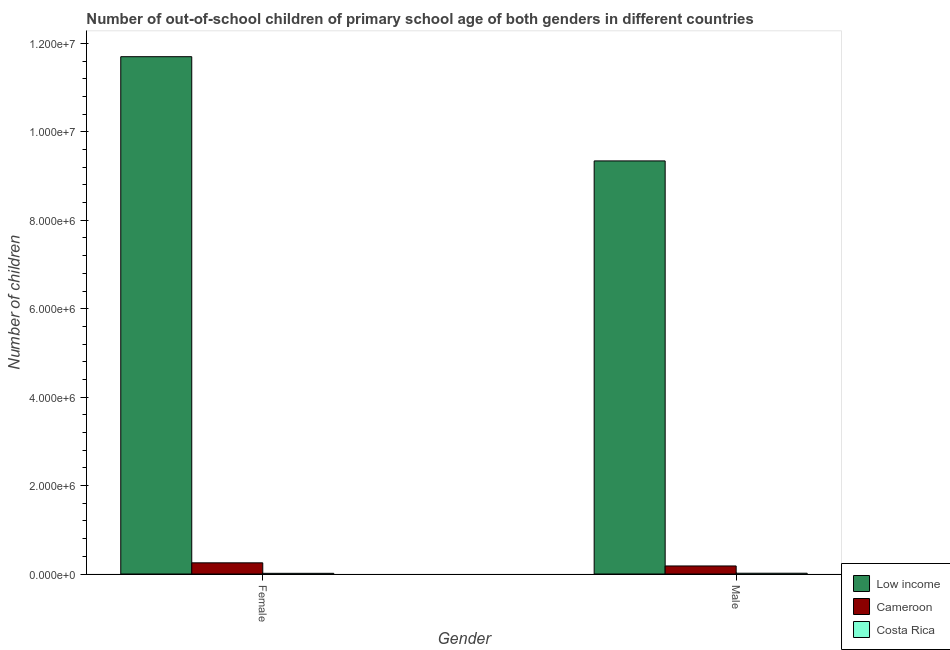Are the number of bars per tick equal to the number of legend labels?
Provide a succinct answer. Yes. How many bars are there on the 2nd tick from the right?
Your response must be concise. 3. What is the number of male out-of-school students in Cameroon?
Your answer should be very brief. 1.82e+05. Across all countries, what is the maximum number of male out-of-school students?
Give a very brief answer. 9.34e+06. Across all countries, what is the minimum number of female out-of-school students?
Your answer should be compact. 1.54e+04. What is the total number of male out-of-school students in the graph?
Make the answer very short. 9.54e+06. What is the difference between the number of female out-of-school students in Low income and that in Costa Rica?
Provide a short and direct response. 1.17e+07. What is the difference between the number of female out-of-school students in Cameroon and the number of male out-of-school students in Low income?
Keep it short and to the point. -9.09e+06. What is the average number of male out-of-school students per country?
Give a very brief answer. 3.18e+06. What is the difference between the number of male out-of-school students and number of female out-of-school students in Costa Rica?
Provide a succinct answer. 2094. In how many countries, is the number of female out-of-school students greater than 5200000 ?
Offer a terse response. 1. What is the ratio of the number of male out-of-school students in Costa Rica to that in Low income?
Your answer should be compact. 0. Is the number of male out-of-school students in Cameroon less than that in Low income?
Provide a short and direct response. Yes. In how many countries, is the number of male out-of-school students greater than the average number of male out-of-school students taken over all countries?
Ensure brevity in your answer.  1. What does the 1st bar from the left in Male represents?
Your response must be concise. Low income. What is the difference between two consecutive major ticks on the Y-axis?
Ensure brevity in your answer.  2.00e+06. Are the values on the major ticks of Y-axis written in scientific E-notation?
Your response must be concise. Yes. Does the graph contain any zero values?
Your response must be concise. No. Does the graph contain grids?
Ensure brevity in your answer.  No. Where does the legend appear in the graph?
Your answer should be very brief. Bottom right. How many legend labels are there?
Your response must be concise. 3. What is the title of the graph?
Give a very brief answer. Number of out-of-school children of primary school age of both genders in different countries. Does "Puerto Rico" appear as one of the legend labels in the graph?
Offer a terse response. No. What is the label or title of the X-axis?
Your response must be concise. Gender. What is the label or title of the Y-axis?
Offer a very short reply. Number of children. What is the Number of children in Low income in Female?
Your answer should be compact. 1.17e+07. What is the Number of children in Cameroon in Female?
Provide a succinct answer. 2.53e+05. What is the Number of children of Costa Rica in Female?
Provide a succinct answer. 1.54e+04. What is the Number of children of Low income in Male?
Keep it short and to the point. 9.34e+06. What is the Number of children in Cameroon in Male?
Offer a terse response. 1.82e+05. What is the Number of children in Costa Rica in Male?
Your response must be concise. 1.75e+04. Across all Gender, what is the maximum Number of children in Low income?
Provide a short and direct response. 1.17e+07. Across all Gender, what is the maximum Number of children in Cameroon?
Offer a terse response. 2.53e+05. Across all Gender, what is the maximum Number of children in Costa Rica?
Provide a short and direct response. 1.75e+04. Across all Gender, what is the minimum Number of children of Low income?
Provide a succinct answer. 9.34e+06. Across all Gender, what is the minimum Number of children of Cameroon?
Give a very brief answer. 1.82e+05. Across all Gender, what is the minimum Number of children in Costa Rica?
Offer a terse response. 1.54e+04. What is the total Number of children of Low income in the graph?
Provide a short and direct response. 2.10e+07. What is the total Number of children of Cameroon in the graph?
Your answer should be compact. 4.34e+05. What is the total Number of children in Costa Rica in the graph?
Offer a terse response. 3.29e+04. What is the difference between the Number of children of Low income in Female and that in Male?
Provide a short and direct response. 2.36e+06. What is the difference between the Number of children of Cameroon in Female and that in Male?
Your answer should be very brief. 7.09e+04. What is the difference between the Number of children of Costa Rica in Female and that in Male?
Offer a terse response. -2094. What is the difference between the Number of children in Low income in Female and the Number of children in Cameroon in Male?
Keep it short and to the point. 1.15e+07. What is the difference between the Number of children of Low income in Female and the Number of children of Costa Rica in Male?
Provide a succinct answer. 1.17e+07. What is the difference between the Number of children of Cameroon in Female and the Number of children of Costa Rica in Male?
Make the answer very short. 2.35e+05. What is the average Number of children in Low income per Gender?
Ensure brevity in your answer.  1.05e+07. What is the average Number of children in Cameroon per Gender?
Ensure brevity in your answer.  2.17e+05. What is the average Number of children in Costa Rica per Gender?
Your response must be concise. 1.65e+04. What is the difference between the Number of children of Low income and Number of children of Cameroon in Female?
Offer a terse response. 1.14e+07. What is the difference between the Number of children in Low income and Number of children in Costa Rica in Female?
Provide a succinct answer. 1.17e+07. What is the difference between the Number of children of Cameroon and Number of children of Costa Rica in Female?
Keep it short and to the point. 2.37e+05. What is the difference between the Number of children in Low income and Number of children in Cameroon in Male?
Offer a very short reply. 9.16e+06. What is the difference between the Number of children of Low income and Number of children of Costa Rica in Male?
Give a very brief answer. 9.33e+06. What is the difference between the Number of children of Cameroon and Number of children of Costa Rica in Male?
Provide a succinct answer. 1.64e+05. What is the ratio of the Number of children of Low income in Female to that in Male?
Ensure brevity in your answer.  1.25. What is the ratio of the Number of children in Cameroon in Female to that in Male?
Offer a terse response. 1.39. What is the ratio of the Number of children in Costa Rica in Female to that in Male?
Your answer should be compact. 0.88. What is the difference between the highest and the second highest Number of children of Low income?
Make the answer very short. 2.36e+06. What is the difference between the highest and the second highest Number of children of Cameroon?
Give a very brief answer. 7.09e+04. What is the difference between the highest and the second highest Number of children of Costa Rica?
Your answer should be compact. 2094. What is the difference between the highest and the lowest Number of children in Low income?
Provide a short and direct response. 2.36e+06. What is the difference between the highest and the lowest Number of children of Cameroon?
Give a very brief answer. 7.09e+04. What is the difference between the highest and the lowest Number of children in Costa Rica?
Give a very brief answer. 2094. 